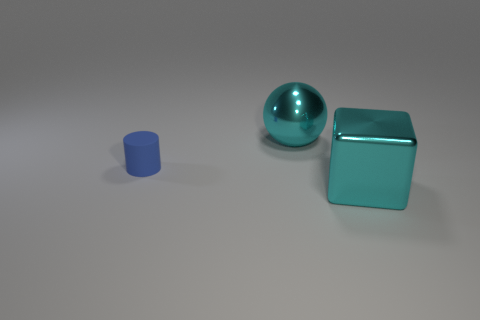Add 3 small purple matte cylinders. How many objects exist? 6 Subtract all cylinders. How many objects are left? 2 Subtract all tiny yellow rubber cylinders. Subtract all tiny things. How many objects are left? 2 Add 3 blue matte objects. How many blue matte objects are left? 4 Add 1 cyan metallic balls. How many cyan metallic balls exist? 2 Subtract 1 cyan cubes. How many objects are left? 2 